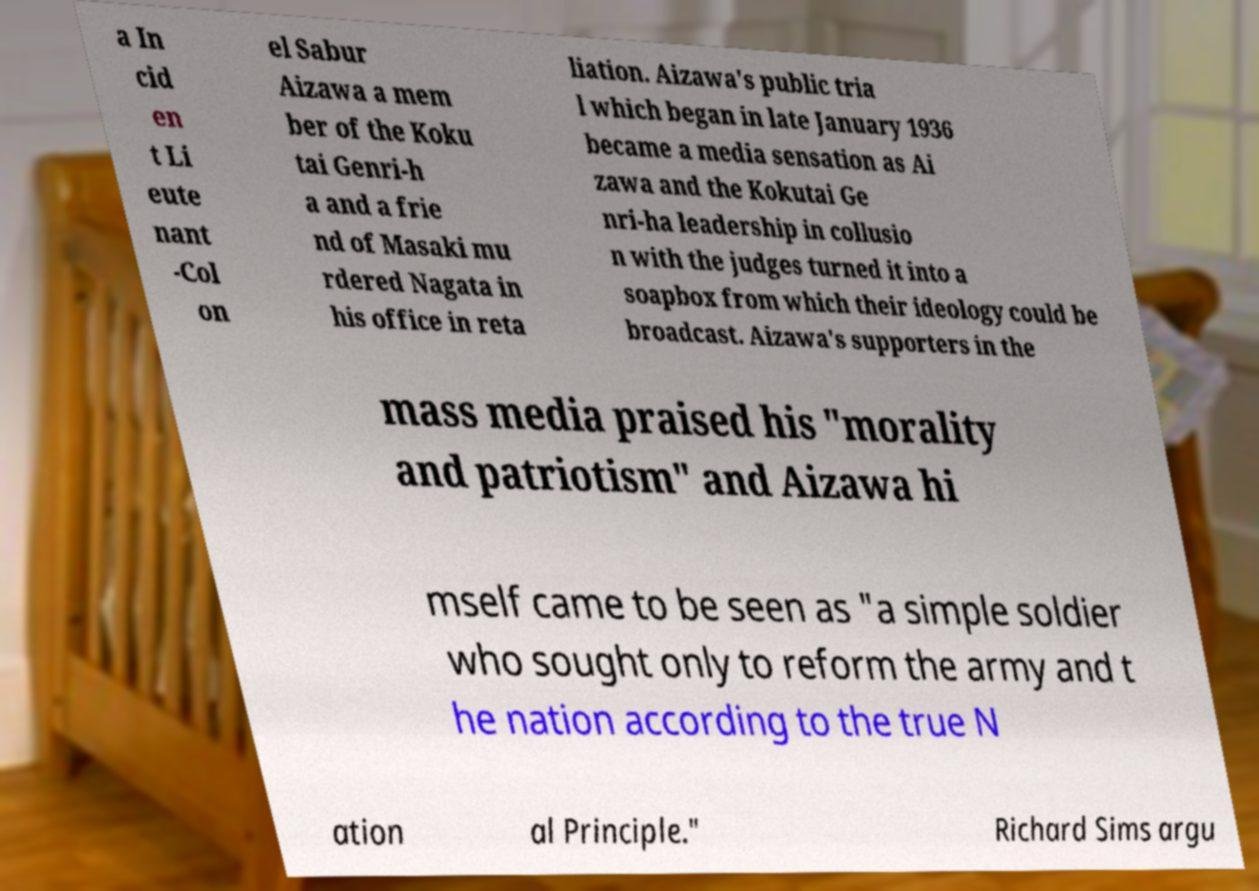Could you assist in decoding the text presented in this image and type it out clearly? a In cid en t Li eute nant -Col on el Sabur Aizawa a mem ber of the Koku tai Genri-h a and a frie nd of Masaki mu rdered Nagata in his office in reta liation. Aizawa's public tria l which began in late January 1936 became a media sensation as Ai zawa and the Kokutai Ge nri-ha leadership in collusio n with the judges turned it into a soapbox from which their ideology could be broadcast. Aizawa's supporters in the mass media praised his "morality and patriotism" and Aizawa hi mself came to be seen as "a simple soldier who sought only to reform the army and t he nation according to the true N ation al Principle." Richard Sims argu 